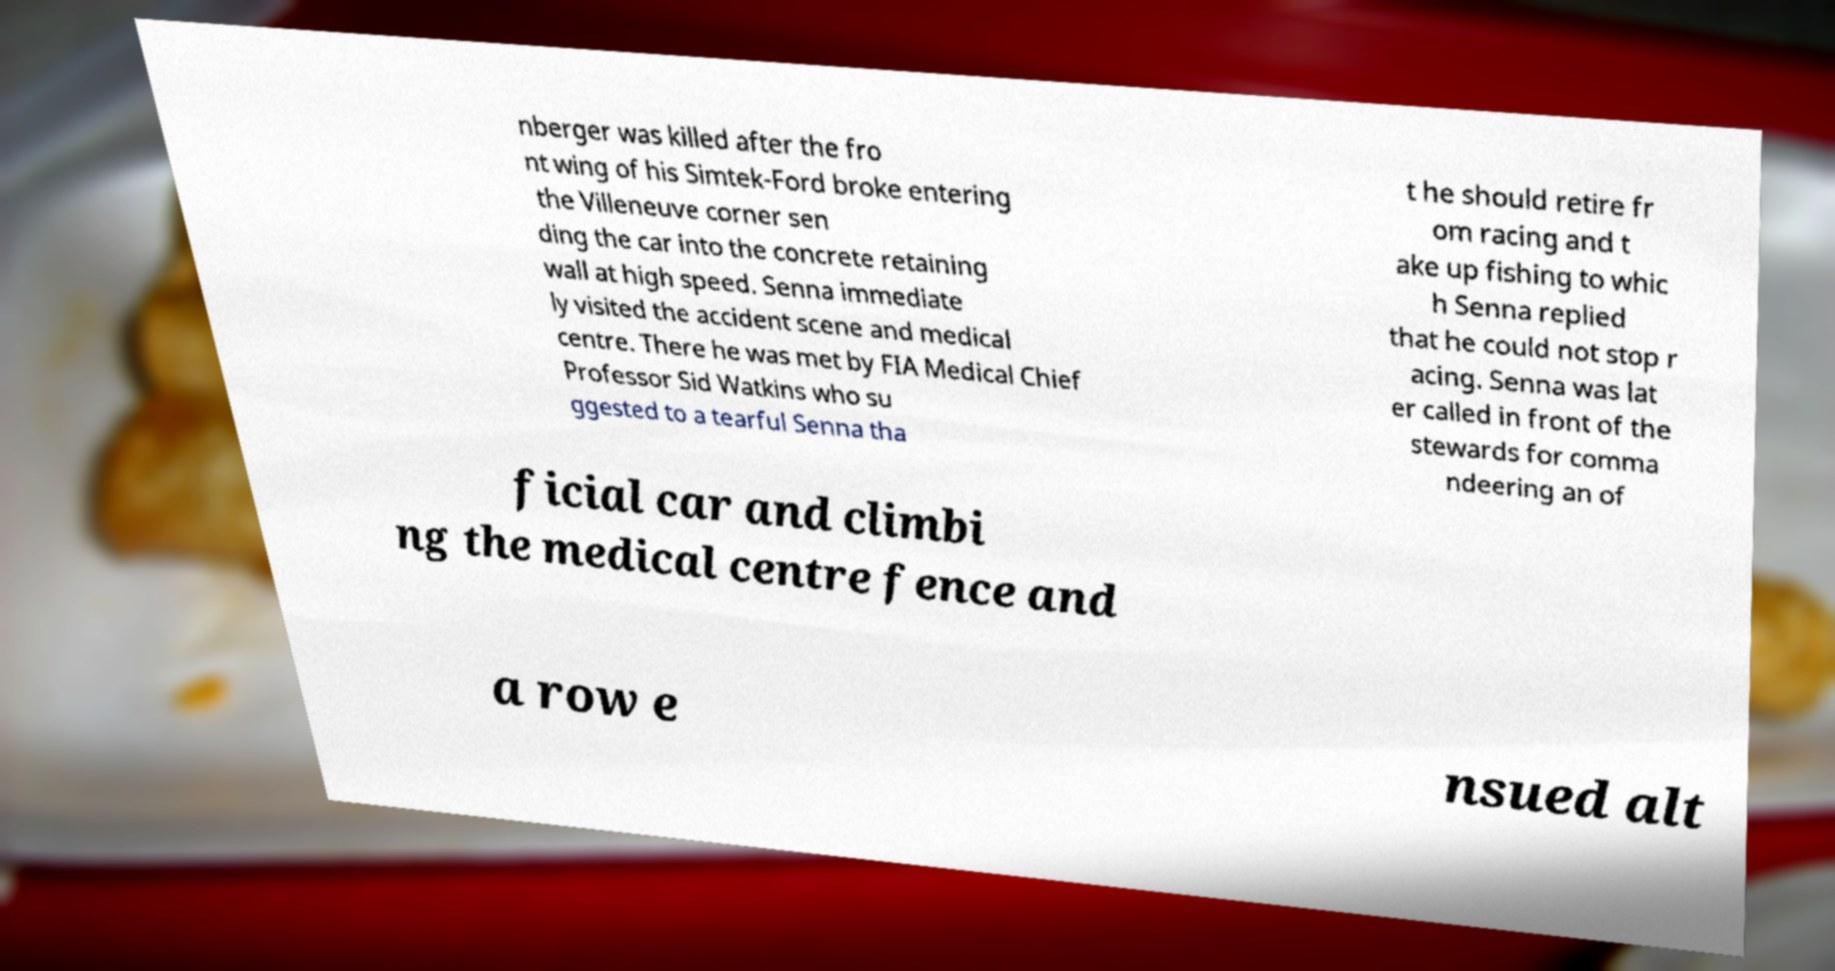Could you assist in decoding the text presented in this image and type it out clearly? nberger was killed after the fro nt wing of his Simtek-Ford broke entering the Villeneuve corner sen ding the car into the concrete retaining wall at high speed. Senna immediate ly visited the accident scene and medical centre. There he was met by FIA Medical Chief Professor Sid Watkins who su ggested to a tearful Senna tha t he should retire fr om racing and t ake up fishing to whic h Senna replied that he could not stop r acing. Senna was lat er called in front of the stewards for comma ndeering an of ficial car and climbi ng the medical centre fence and a row e nsued alt 